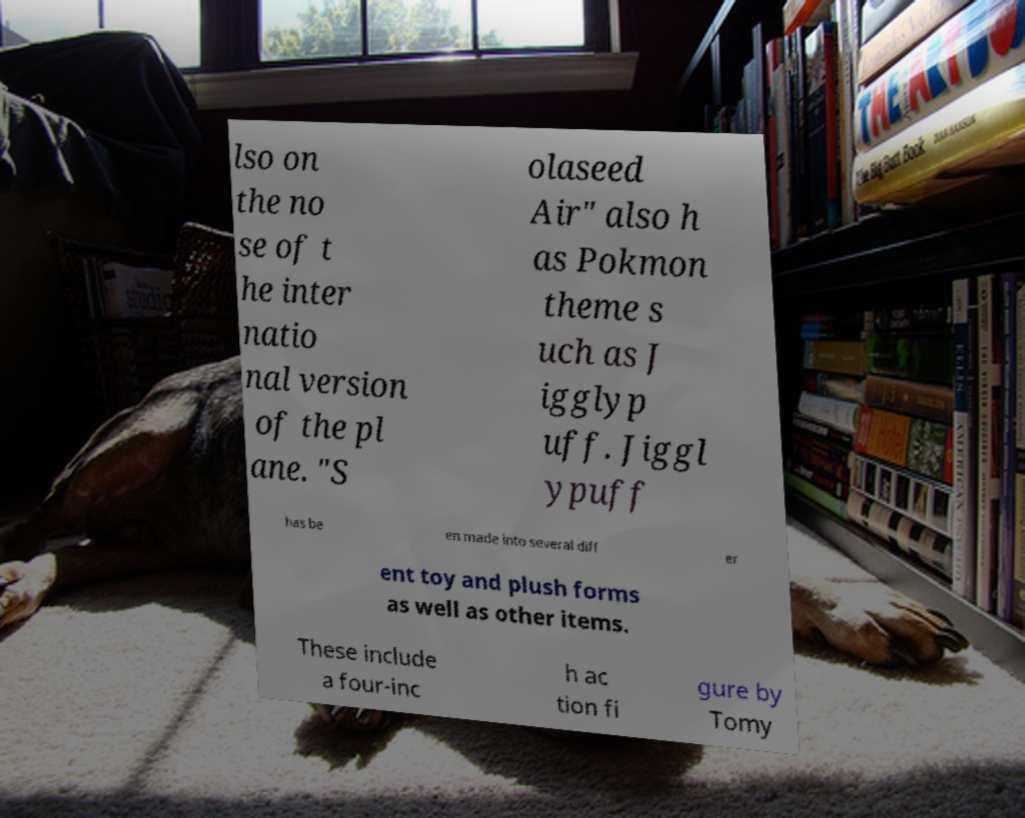What messages or text are displayed in this image? I need them in a readable, typed format. lso on the no se of t he inter natio nal version of the pl ane. "S olaseed Air" also h as Pokmon theme s uch as J igglyp uff. Jiggl ypuff has be en made into several diff er ent toy and plush forms as well as other items. These include a four-inc h ac tion fi gure by Tomy 